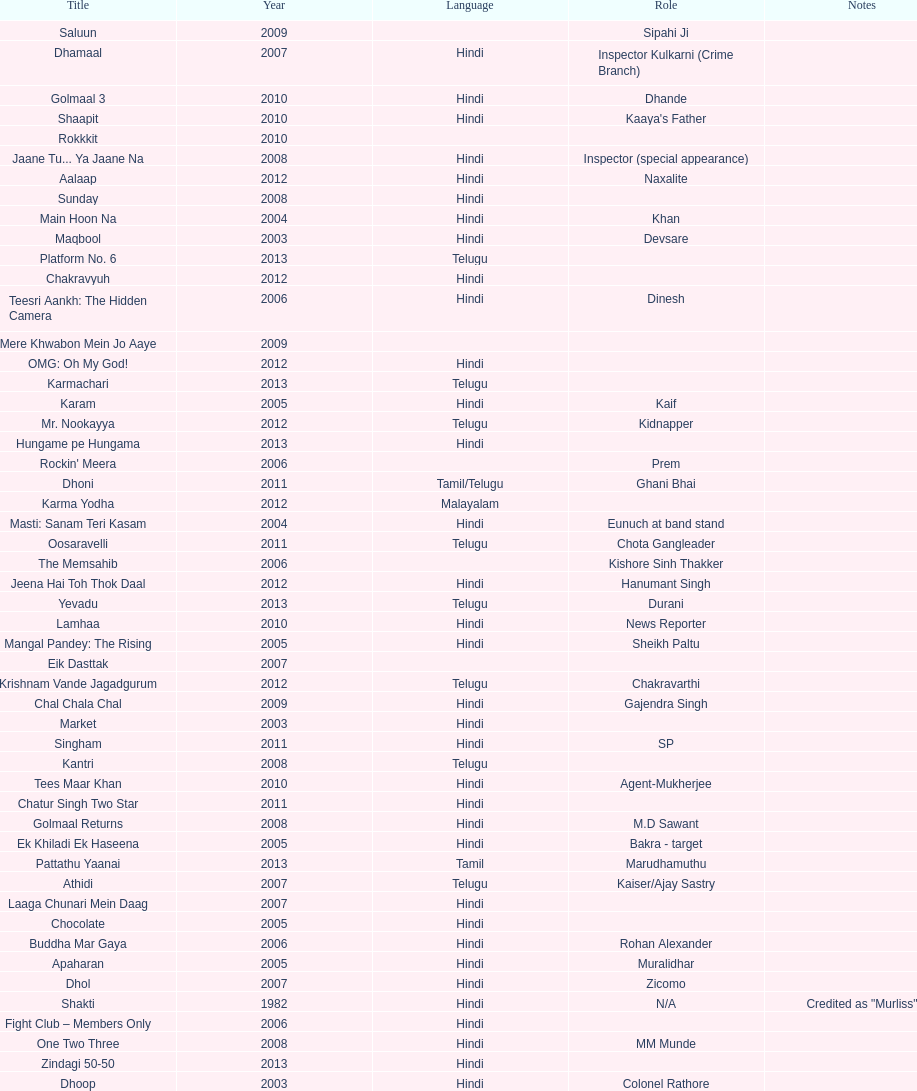What is the title prior to dhol in 2007? Dhamaal. Can you parse all the data within this table? {'header': ['Title', 'Year', 'Language', 'Role', 'Notes'], 'rows': [['Saluun', '2009', '', 'Sipahi Ji', ''], ['Dhamaal', '2007', 'Hindi', 'Inspector Kulkarni (Crime Branch)', ''], ['Golmaal 3', '2010', 'Hindi', 'Dhande', ''], ['Shaapit', '2010', 'Hindi', "Kaaya's Father", ''], ['Rokkkit', '2010', '', '', ''], ['Jaane Tu... Ya Jaane Na', '2008', 'Hindi', 'Inspector (special appearance)', ''], ['Aalaap', '2012', 'Hindi', 'Naxalite', ''], ['Sunday', '2008', 'Hindi', '', ''], ['Main Hoon Na', '2004', 'Hindi', 'Khan', ''], ['Maqbool', '2003', 'Hindi', 'Devsare', ''], ['Platform No. 6', '2013', 'Telugu', '', ''], ['Chakravyuh', '2012', 'Hindi', '', ''], ['Teesri Aankh: The Hidden Camera', '2006', 'Hindi', 'Dinesh', ''], ['Mere Khwabon Mein Jo Aaye', '2009', '', '', ''], ['OMG: Oh My God!', '2012', 'Hindi', '', ''], ['Karmachari', '2013', 'Telugu', '', ''], ['Karam', '2005', 'Hindi', 'Kaif', ''], ['Mr. Nookayya', '2012', 'Telugu', 'Kidnapper', ''], ['Hungame pe Hungama', '2013', 'Hindi', '', ''], ["Rockin' Meera", '2006', '', 'Prem', ''], ['Dhoni', '2011', 'Tamil/Telugu', 'Ghani Bhai', ''], ['Karma Yodha', '2012', 'Malayalam', '', ''], ['Masti: Sanam Teri Kasam', '2004', 'Hindi', 'Eunuch at band stand', ''], ['Oosaravelli', '2011', 'Telugu', 'Chota Gangleader', ''], ['The Memsahib', '2006', '', 'Kishore Sinh Thakker', ''], ['Jeena Hai Toh Thok Daal', '2012', 'Hindi', 'Hanumant Singh', ''], ['Yevadu', '2013', 'Telugu', 'Durani', ''], ['Lamhaa', '2010', 'Hindi', 'News Reporter', ''], ['Mangal Pandey: The Rising', '2005', 'Hindi', 'Sheikh Paltu', ''], ['Eik Dasttak', '2007', '', '', ''], ['Krishnam Vande Jagadgurum', '2012', 'Telugu', 'Chakravarthi', ''], ['Chal Chala Chal', '2009', 'Hindi', 'Gajendra Singh', ''], ['Market', '2003', 'Hindi', '', ''], ['Singham', '2011', 'Hindi', 'SP', ''], ['Kantri', '2008', 'Telugu', '', ''], ['Tees Maar Khan', '2010', 'Hindi', 'Agent-Mukherjee', ''], ['Chatur Singh Two Star', '2011', 'Hindi', '', ''], ['Golmaal Returns', '2008', 'Hindi', 'M.D Sawant', ''], ['Ek Khiladi Ek Haseena', '2005', 'Hindi', 'Bakra - target', ''], ['Pattathu Yaanai', '2013', 'Tamil', 'Marudhamuthu', ''], ['Athidi', '2007', 'Telugu', 'Kaiser/Ajay Sastry', ''], ['Laaga Chunari Mein Daag', '2007', 'Hindi', '', ''], ['Chocolate', '2005', 'Hindi', '', ''], ['Buddha Mar Gaya', '2006', 'Hindi', 'Rohan Alexander', ''], ['Apaharan', '2005', 'Hindi', 'Muralidhar', ''], ['Dhol', '2007', 'Hindi', 'Zicomo', ''], ['Shakti', '1982', 'Hindi', 'N/A', 'Credited as "Murliss"'], ['Fight Club – Members Only', '2006', 'Hindi', '', ''], ['One Two Three', '2008', 'Hindi', 'MM Munde', ''], ['Zindagi 50-50', '2013', 'Hindi', '', ''], ['Dhoop', '2003', 'Hindi', 'Colonel Rathore', ''], ['Dabangg', '2010', 'Hindi', '', ''], ['13B: Fear Has a New Address', '2009', 'Tamil/Hindi', 'Inspector Shiva', ''], ['Kal: Yesterday and Tomorrow', '2005', 'Hindi', 'Sekhar', ''], ['Black Friday', '2004', 'Hindi', '', ''], ['Dil Vil Pyar Vyar', '2002', 'Hindi', 'N/A', ''], ['Choron Ki Baraat', '2012', 'Hindi', 'Tejeshwar Singh', '']]} 